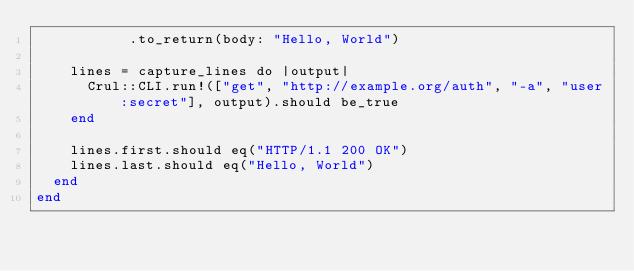<code> <loc_0><loc_0><loc_500><loc_500><_Crystal_>           .to_return(body: "Hello, World")

    lines = capture_lines do |output|
      Crul::CLI.run!(["get", "http://example.org/auth", "-a", "user:secret"], output).should be_true
    end

    lines.first.should eq("HTTP/1.1 200 OK")
    lines.last.should eq("Hello, World")
  end
end
</code> 